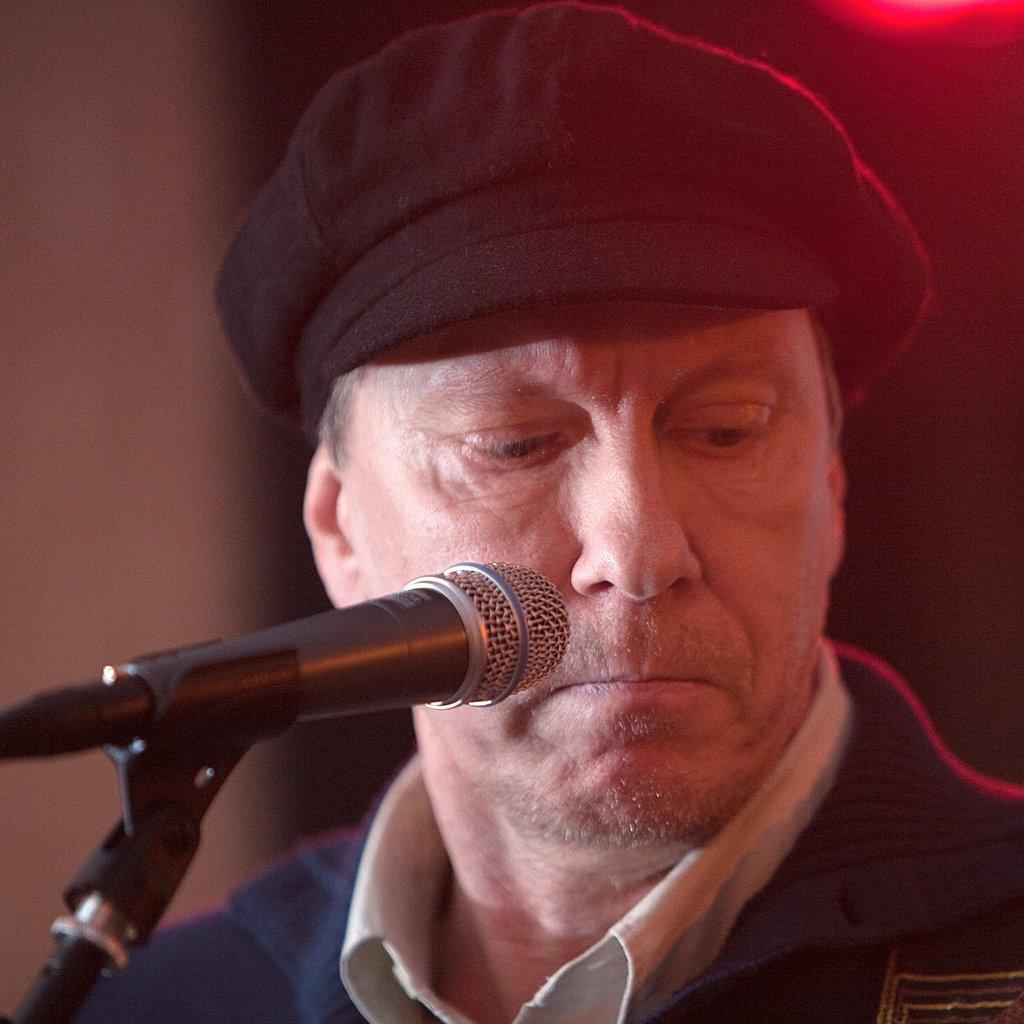Please provide a concise description of this image. In the bottom left side of the image there is a microphone. Behind the microphone a man is there. 